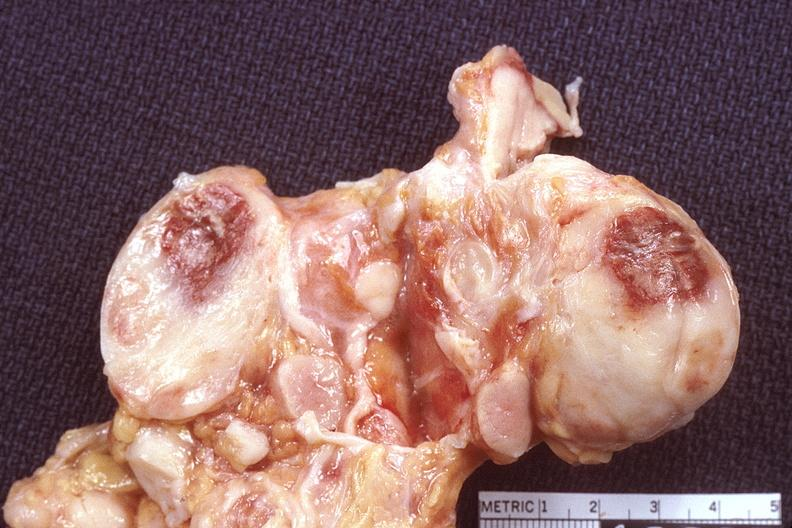does lesion show lymph nodes, lymphoma?
Answer the question using a single word or phrase. No 